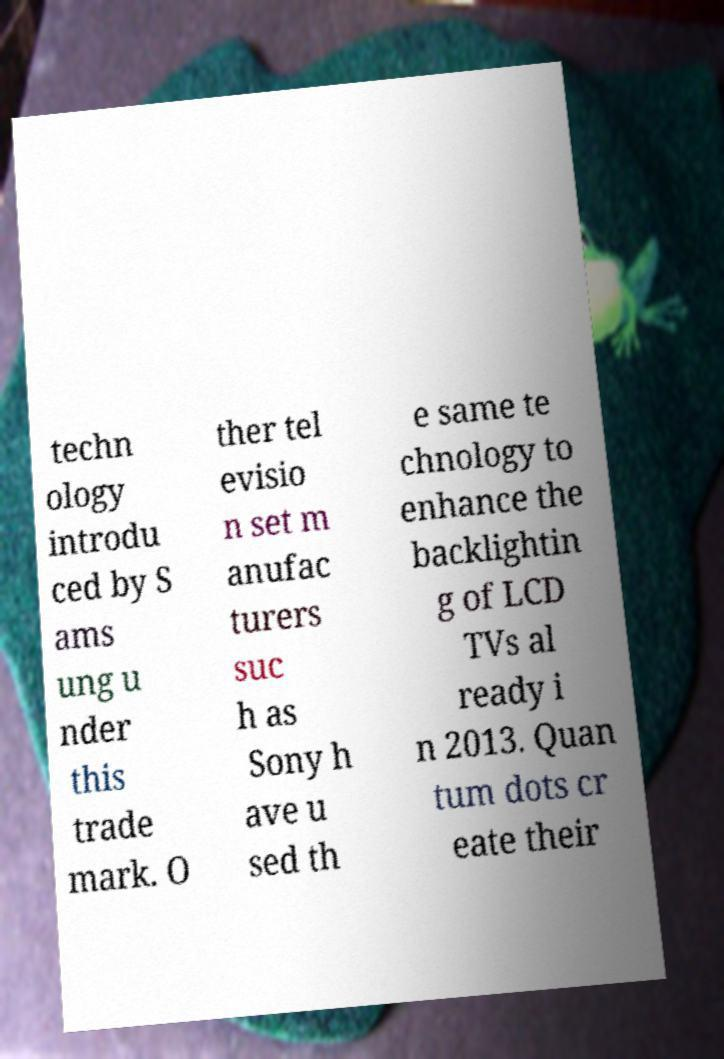Please read and relay the text visible in this image. What does it say? techn ology introdu ced by S ams ung u nder this trade mark. O ther tel evisio n set m anufac turers suc h as Sony h ave u sed th e same te chnology to enhance the backlightin g of LCD TVs al ready i n 2013. Quan tum dots cr eate their 